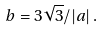Convert formula to latex. <formula><loc_0><loc_0><loc_500><loc_500>b = 3 \sqrt { 3 } / | a | \, .</formula> 